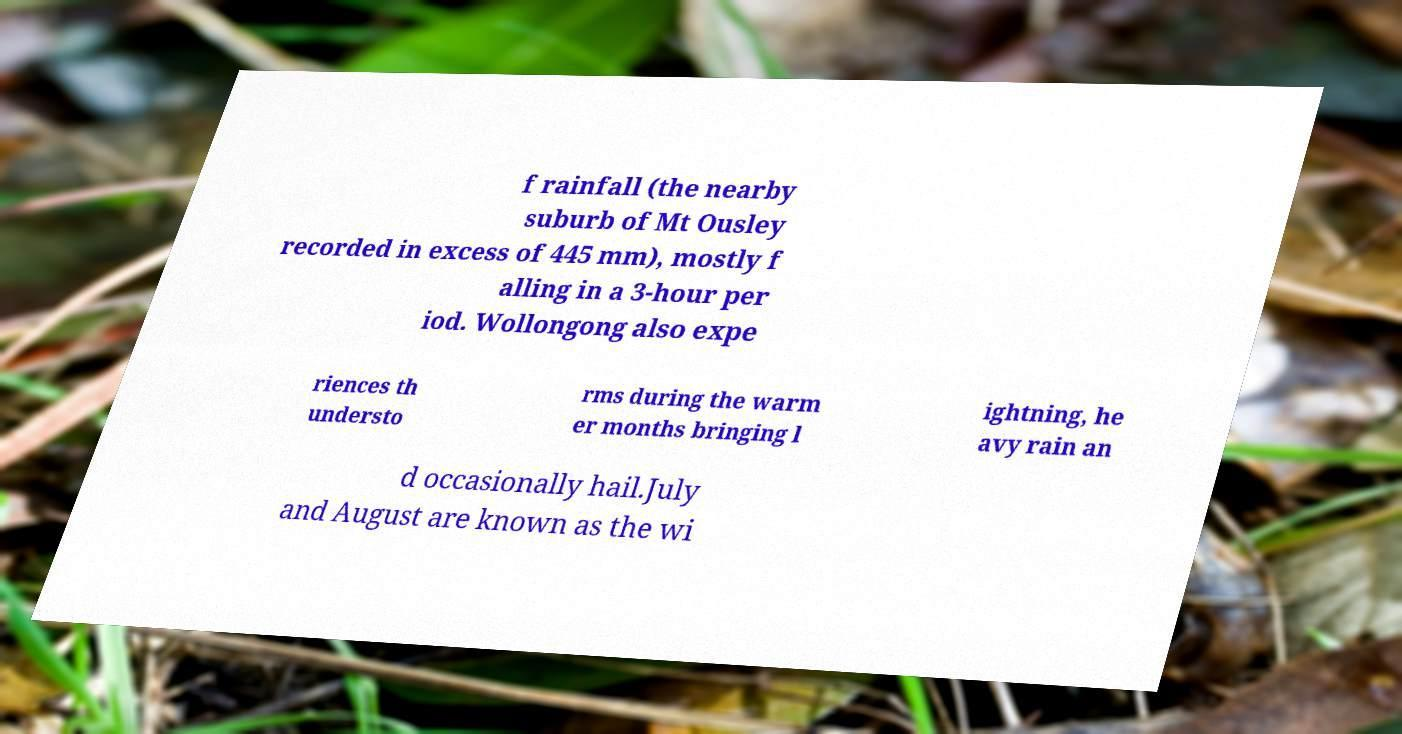Could you extract and type out the text from this image? f rainfall (the nearby suburb of Mt Ousley recorded in excess of 445 mm), mostly f alling in a 3-hour per iod. Wollongong also expe riences th understo rms during the warm er months bringing l ightning, he avy rain an d occasionally hail.July and August are known as the wi 